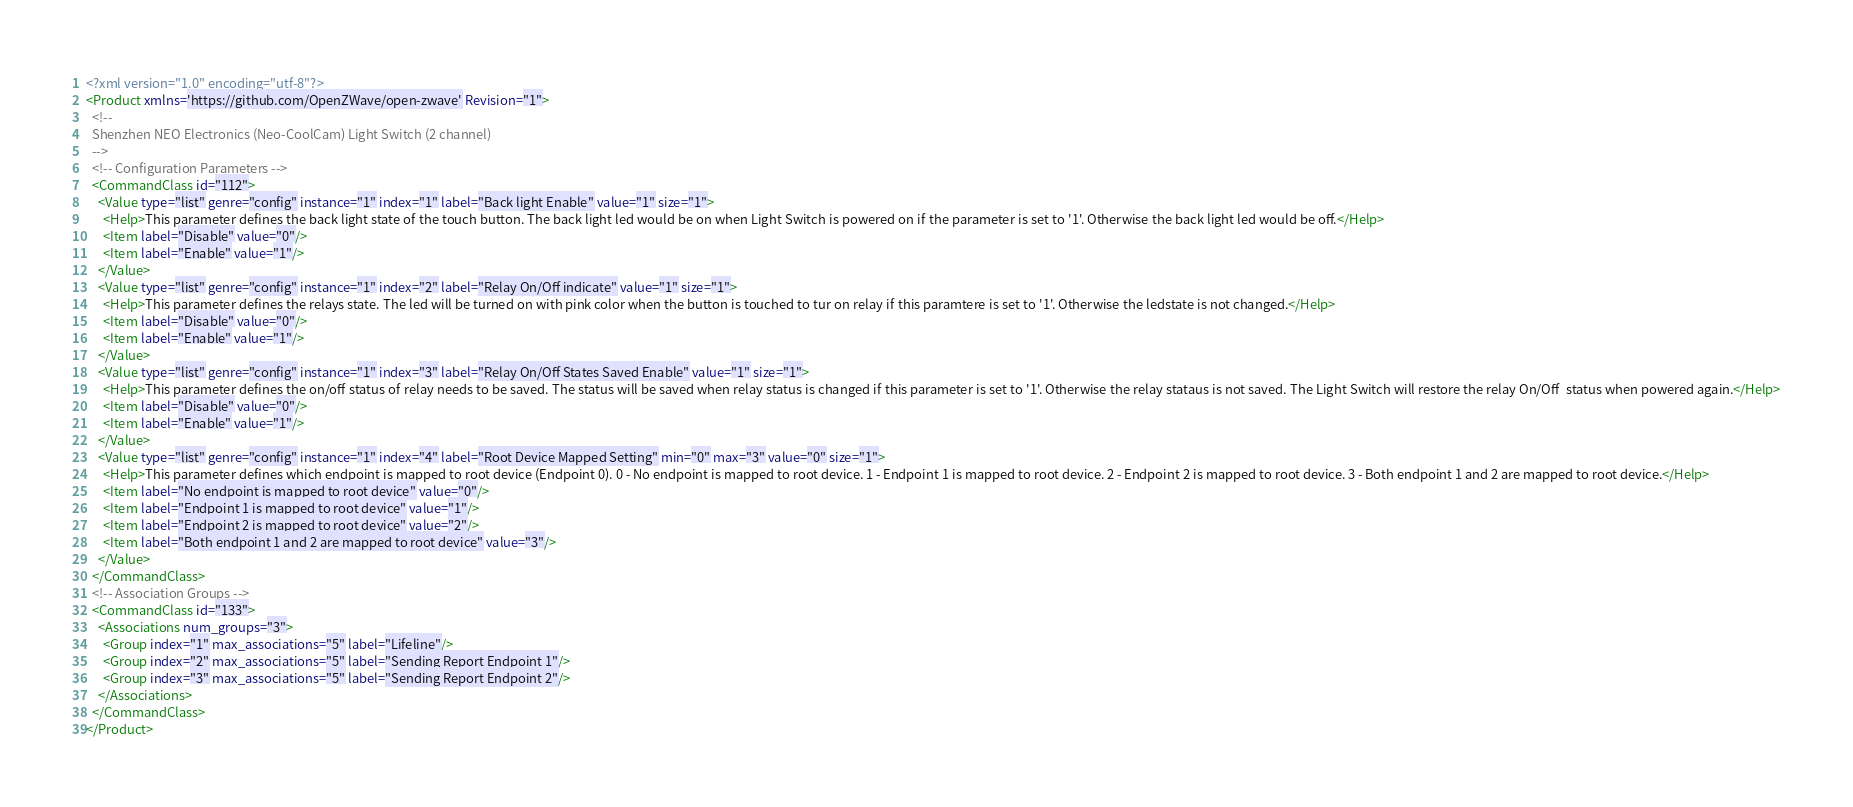Convert code to text. <code><loc_0><loc_0><loc_500><loc_500><_XML_><?xml version="1.0" encoding="utf-8"?>
<Product xmlns='https://github.com/OpenZWave/open-zwave' Revision="1">
  <!--
  Shenzhen NEO Electronics (Neo-CoolCam) Light Switch (2 channel)
  -->
  <!-- Configuration Parameters -->
  <CommandClass id="112">
    <Value type="list" genre="config" instance="1" index="1" label="Back light Enable" value="1" size="1">
      <Help>This parameter defines the back light state of the touch button. The back light led would be on when Light Switch is powered on if the parameter is set to '1'. Otherwise the back light led would be off.</Help>
      <Item label="Disable" value="0"/>
      <Item label="Enable" value="1"/>
    </Value>
    <Value type="list" genre="config" instance="1" index="2" label="Relay On/Off indicate" value="1" size="1">
      <Help>This parameter defines the relays state. The led will be turned on with pink color when the button is touched to tur on relay if this paramtere is set to '1'. Otherwise the ledstate is not changed.</Help>
      <Item label="Disable" value="0"/>
      <Item label="Enable" value="1"/>
    </Value>
    <Value type="list" genre="config" instance="1" index="3" label="Relay On/Off States Saved Enable" value="1" size="1">
      <Help>This parameter defines the on/off status of relay needs to be saved. The status will be saved when relay status is changed if this parameter is set to '1'. Otherwise the relay stataus is not saved. The Light Switch will restore the relay On/Off  status when powered again.</Help>
      <Item label="Disable" value="0"/>
      <Item label="Enable" value="1"/>
    </Value>
    <Value type="list" genre="config" instance="1" index="4" label="Root Device Mapped Setting" min="0" max="3" value="0" size="1">
      <Help>This parameter defines which endpoint is mapped to root device (Endpoint 0). 0 - No endpoint is mapped to root device. 1 - Endpoint 1 is mapped to root device. 2 - Endpoint 2 is mapped to root device. 3 - Both endpoint 1 and 2 are mapped to root device.</Help>
      <Item label="No endpoint is mapped to root device" value="0"/>
      <Item label="Endpoint 1 is mapped to root device" value="1"/>
      <Item label="Endpoint 2 is mapped to root device" value="2"/>
      <Item label="Both endpoint 1 and 2 are mapped to root device" value="3"/>
    </Value>
  </CommandClass>
  <!-- Association Groups -->
  <CommandClass id="133">
    <Associations num_groups="3">
      <Group index="1" max_associations="5" label="Lifeline"/>
      <Group index="2" max_associations="5" label="Sending Report Endpoint 1"/>
      <Group index="3" max_associations="5" label="Sending Report Endpoint 2"/>
    </Associations>
  </CommandClass>
</Product>
</code> 